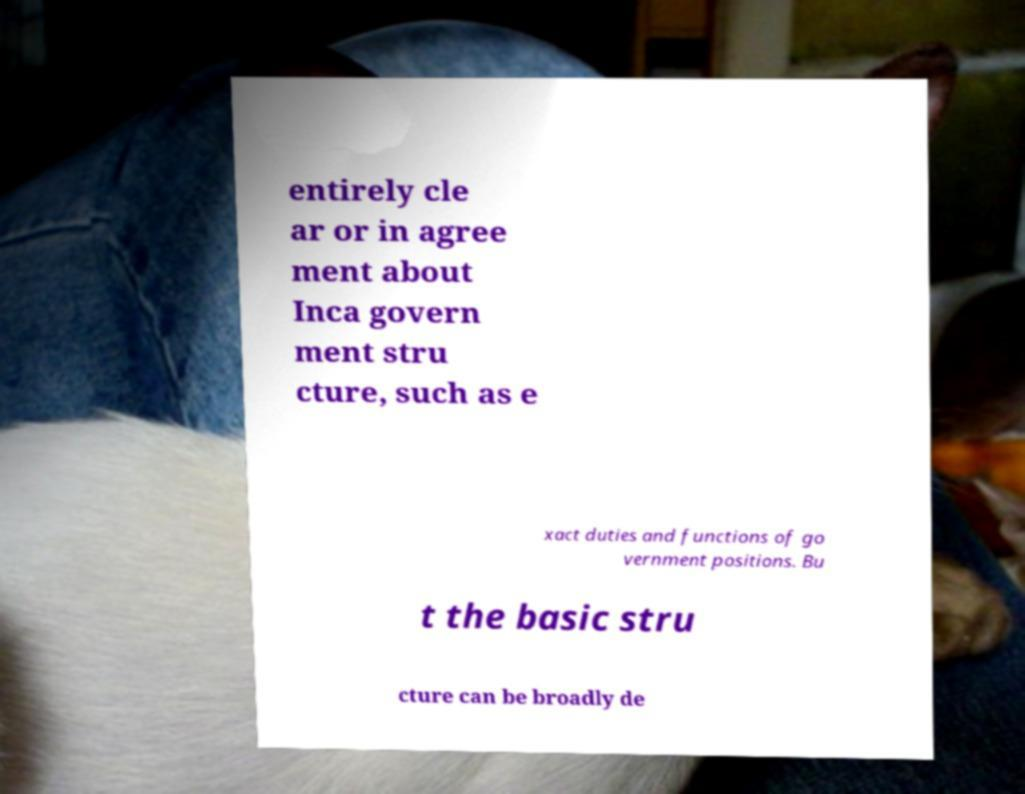Can you accurately transcribe the text from the provided image for me? entirely cle ar or in agree ment about Inca govern ment stru cture, such as e xact duties and functions of go vernment positions. Bu t the basic stru cture can be broadly de 